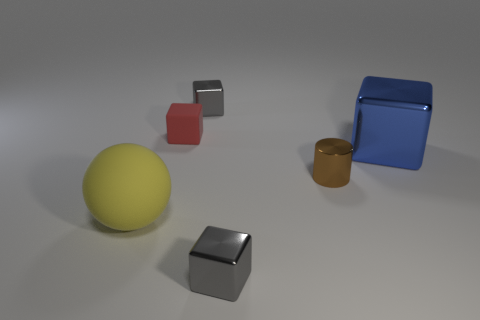What number of other objects are there of the same material as the ball?
Ensure brevity in your answer.  1. Is the number of large yellow things that are right of the blue block the same as the number of small red rubber objects?
Your answer should be very brief. No. There is a brown cylinder; is it the same size as the matte thing that is left of the tiny red rubber object?
Your answer should be very brief. No. The large object in front of the brown metal thing has what shape?
Offer a terse response. Sphere. Is there anything else that is the same shape as the yellow thing?
Offer a very short reply. No. Are any spheres visible?
Ensure brevity in your answer.  Yes. There is a gray object behind the large blue cube; is its size the same as the shiny block in front of the small brown shiny cylinder?
Your answer should be very brief. Yes. What is the thing that is in front of the tiny shiny cylinder and on the right side of the large yellow ball made of?
Provide a short and direct response. Metal. There is a brown shiny thing; what number of metallic blocks are in front of it?
Provide a short and direct response. 1. Is there anything else that has the same size as the brown shiny object?
Your answer should be compact. Yes. 